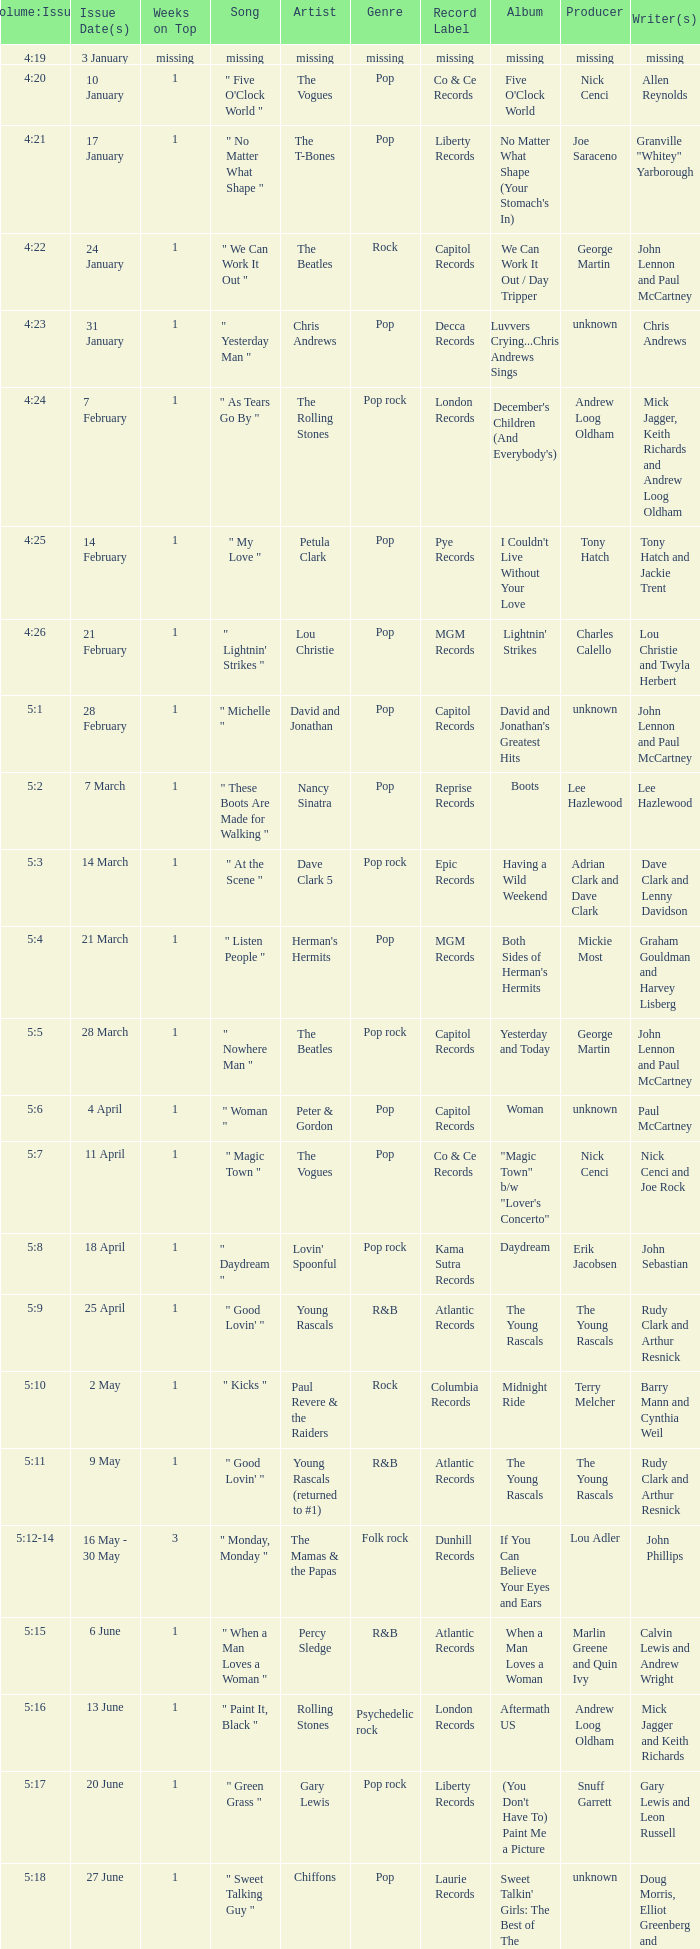Volume:Issue of 5:16 has what song listed? " Paint It, Black ". 